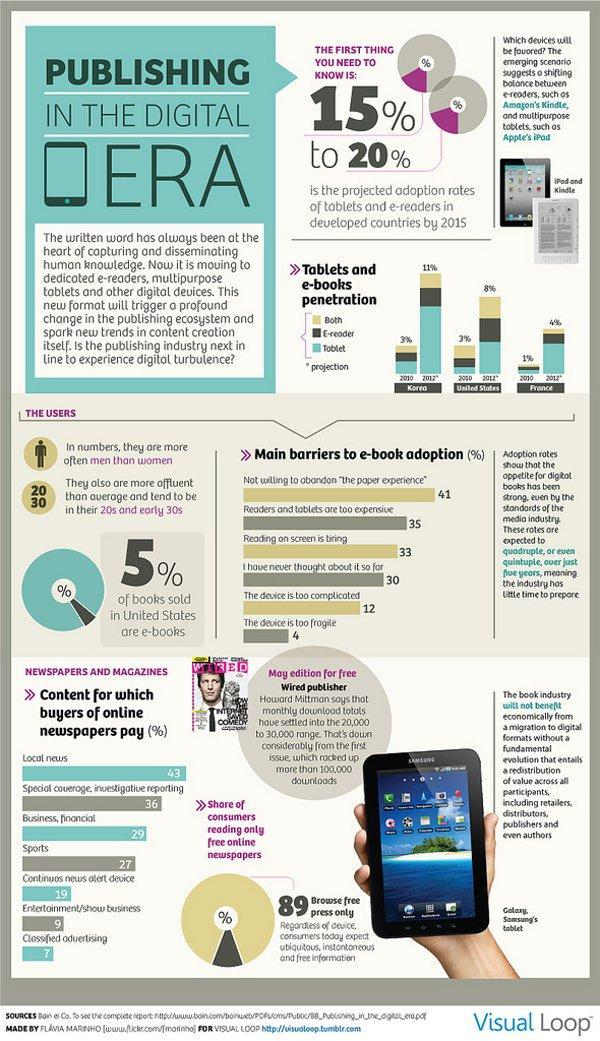In France during 2012, which device will be used most according to the projection?
Answer the question with a short phrase. Tablet Which country is projected to have the highest tablets and e-books penetration in 2012? Korea Which gender uses ebooks more? men What percent think that the device is too complicated and fragile? 16% What percent of buyers of online newspapers pay for continuous news alert device and entertainment/show business? 28% 